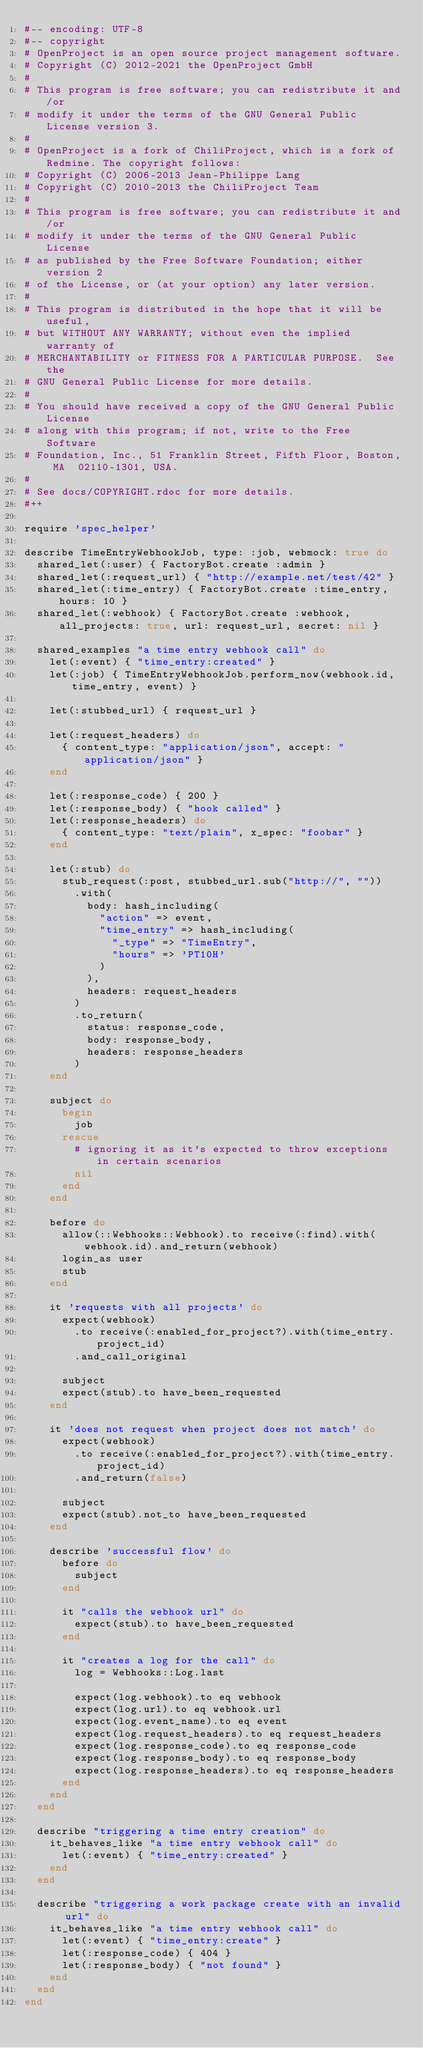Convert code to text. <code><loc_0><loc_0><loc_500><loc_500><_Ruby_>#-- encoding: UTF-8
#-- copyright
# OpenProject is an open source project management software.
# Copyright (C) 2012-2021 the OpenProject GmbH
#
# This program is free software; you can redistribute it and/or
# modify it under the terms of the GNU General Public License version 3.
#
# OpenProject is a fork of ChiliProject, which is a fork of Redmine. The copyright follows:
# Copyright (C) 2006-2013 Jean-Philippe Lang
# Copyright (C) 2010-2013 the ChiliProject Team
#
# This program is free software; you can redistribute it and/or
# modify it under the terms of the GNU General Public License
# as published by the Free Software Foundation; either version 2
# of the License, or (at your option) any later version.
#
# This program is distributed in the hope that it will be useful,
# but WITHOUT ANY WARRANTY; without even the implied warranty of
# MERCHANTABILITY or FITNESS FOR A PARTICULAR PURPOSE.  See the
# GNU General Public License for more details.
#
# You should have received a copy of the GNU General Public License
# along with this program; if not, write to the Free Software
# Foundation, Inc., 51 Franklin Street, Fifth Floor, Boston, MA  02110-1301, USA.
#
# See docs/COPYRIGHT.rdoc for more details.
#++

require 'spec_helper'

describe TimeEntryWebhookJob, type: :job, webmock: true do
  shared_let(:user) { FactoryBot.create :admin }
  shared_let(:request_url) { "http://example.net/test/42" }
  shared_let(:time_entry) { FactoryBot.create :time_entry, hours: 10 }
  shared_let(:webhook) { FactoryBot.create :webhook, all_projects: true, url: request_url, secret: nil }

  shared_examples "a time entry webhook call" do
    let(:event) { "time_entry:created" }
    let(:job) { TimeEntryWebhookJob.perform_now(webhook.id, time_entry, event) }

    let(:stubbed_url) { request_url }

    let(:request_headers) do
      { content_type: "application/json", accept: "application/json" }
    end

    let(:response_code) { 200 }
    let(:response_body) { "hook called" }
    let(:response_headers) do
      { content_type: "text/plain", x_spec: "foobar" }
    end

    let(:stub) do
      stub_request(:post, stubbed_url.sub("http://", ""))
        .with(
          body: hash_including(
            "action" => event,
            "time_entry" => hash_including(
              "_type" => "TimeEntry",
              "hours" => 'PT10H'
            )
          ),
          headers: request_headers
        )
        .to_return(
          status: response_code,
          body: response_body,
          headers: response_headers
        )
    end

    subject do
      begin
        job
      rescue
        # ignoring it as it's expected to throw exceptions in certain scenarios
        nil
      end
    end

    before do
      allow(::Webhooks::Webhook).to receive(:find).with(webhook.id).and_return(webhook)
      login_as user
      stub
    end

    it 'requests with all projects' do
      expect(webhook)
        .to receive(:enabled_for_project?).with(time_entry.project_id)
        .and_call_original

      subject
      expect(stub).to have_been_requested
    end

    it 'does not request when project does not match' do
      expect(webhook)
        .to receive(:enabled_for_project?).with(time_entry.project_id)
        .and_return(false)

      subject
      expect(stub).not_to have_been_requested
    end

    describe 'successful flow' do
      before do
        subject
      end

      it "calls the webhook url" do
        expect(stub).to have_been_requested
      end

      it "creates a log for the call" do
        log = Webhooks::Log.last

        expect(log.webhook).to eq webhook
        expect(log.url).to eq webhook.url
        expect(log.event_name).to eq event
        expect(log.request_headers).to eq request_headers
        expect(log.response_code).to eq response_code
        expect(log.response_body).to eq response_body
        expect(log.response_headers).to eq response_headers
      end
    end
  end

  describe "triggering a time entry creation" do
    it_behaves_like "a time entry webhook call" do
      let(:event) { "time_entry:created" }
    end
  end

  describe "triggering a work package create with an invalid url" do
    it_behaves_like "a time entry webhook call" do
      let(:event) { "time_entry:create" }
      let(:response_code) { 404 }
      let(:response_body) { "not found" }
    end
  end
end
</code> 